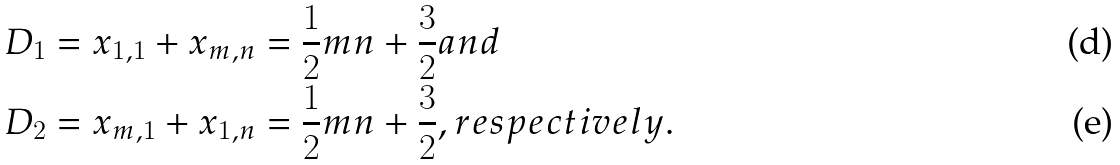Convert formula to latex. <formula><loc_0><loc_0><loc_500><loc_500>D _ { 1 } & = x _ { 1 , 1 } + x _ { m , n } = \frac { 1 } { 2 } m n + \frac { 3 } { 2 } a n d \\ D _ { 2 } & = x _ { m , 1 } + x _ { 1 , n } = \frac { 1 } { 2 } m n + \frac { 3 } { 2 } , r e s p e c t i v e l y .</formula> 